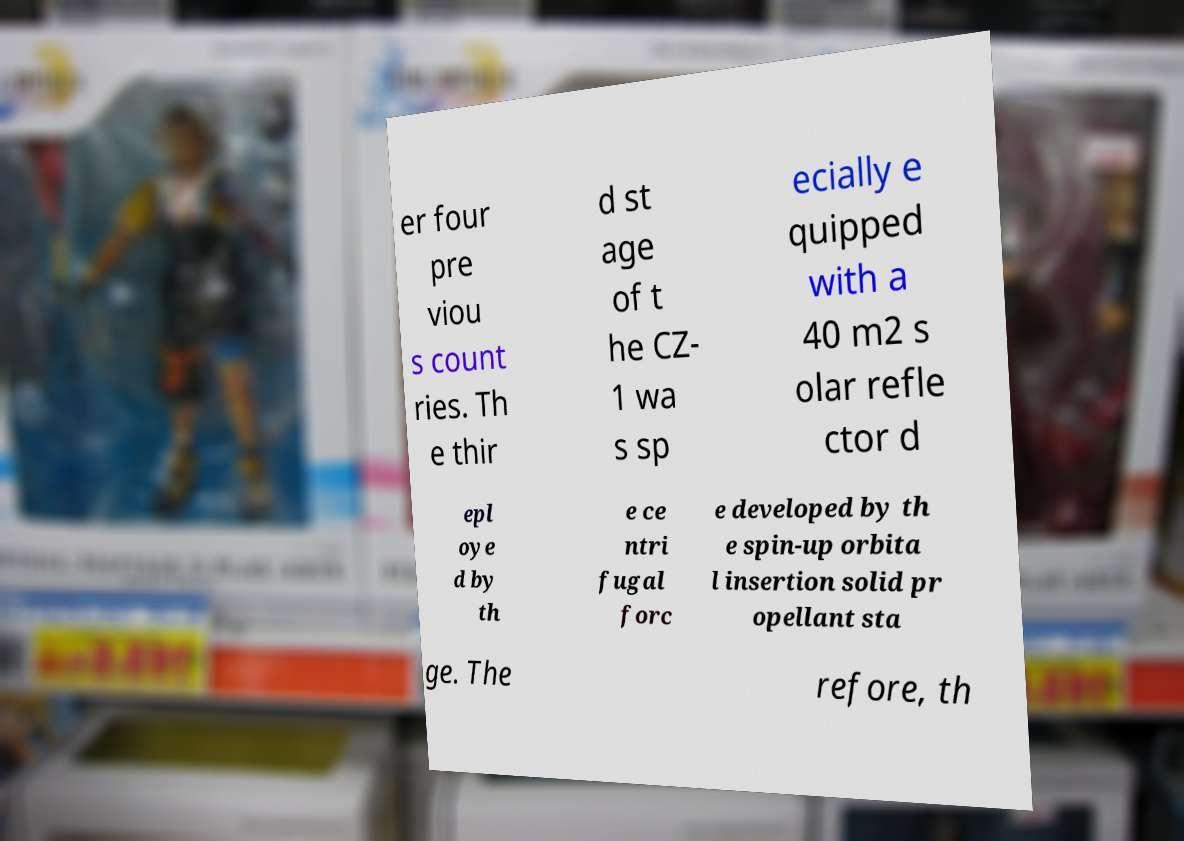Please identify and transcribe the text found in this image. er four pre viou s count ries. Th e thir d st age of t he CZ- 1 wa s sp ecially e quipped with a 40 m2 s olar refle ctor d epl oye d by th e ce ntri fugal forc e developed by th e spin-up orbita l insertion solid pr opellant sta ge. The refore, th 